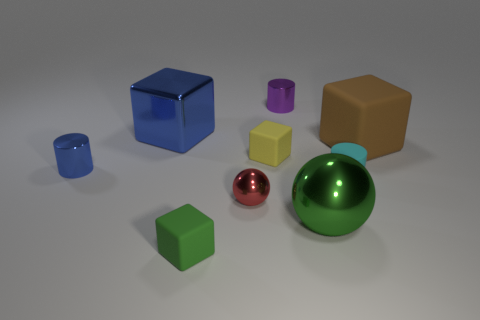There is a tiny thing that is behind the brown rubber block; is its color the same as the large shiny sphere?
Offer a very short reply. No. How many brown objects are matte balls or tiny shiny objects?
Provide a short and direct response. 0. The cylinder that is behind the matte cube that is right of the large green metal object is what color?
Give a very brief answer. Purple. There is a small object that is the same color as the large metallic block; what is its material?
Make the answer very short. Metal. There is a metal cylinder behind the big blue thing; what is its color?
Your response must be concise. Purple. There is a rubber block that is on the right side of the cyan object; does it have the same size as the rubber cylinder?
Provide a short and direct response. No. What size is the block that is the same color as the large ball?
Ensure brevity in your answer.  Small. Is there a green shiny object that has the same size as the purple shiny cylinder?
Make the answer very short. No. There is a small rubber cube left of the red metallic object; is its color the same as the cylinder behind the blue block?
Give a very brief answer. No. Are there any large things that have the same color as the metallic cube?
Provide a succinct answer. No. 